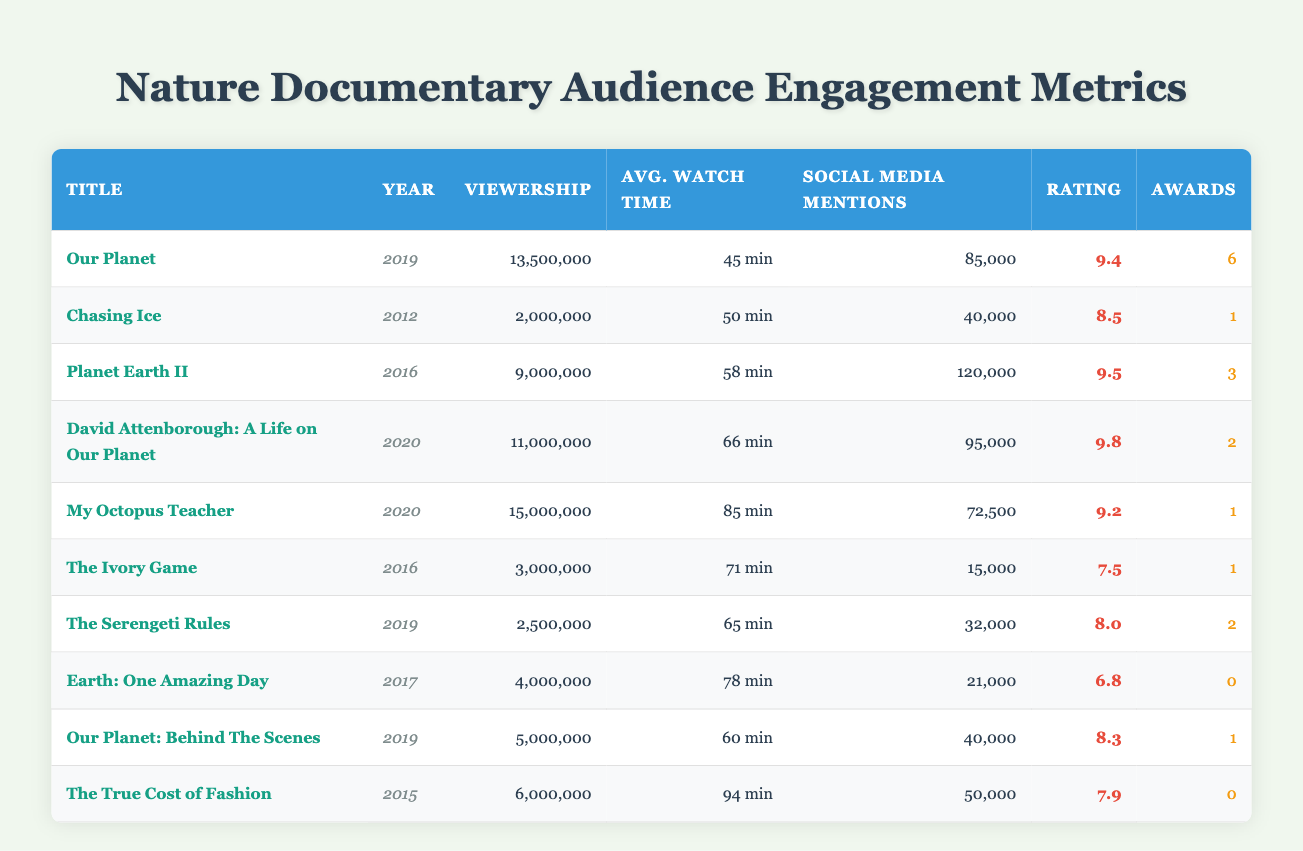What nature documentary had the highest viewership? By looking at the viewership numbers in the table, "My Octopus Teacher" has the highest viewership at 15,000,000.
Answer: My Octopus Teacher Which nature documentary won the most awards? From the table, "Our Planet" won the most awards at 6.
Answer: Our Planet What is the average watch time for the documentaries released in 2020? First, add the average watch times of "David Attenborough: A Life on Our Planet" (66 min) and "My Octopus Teacher" (85 min) to get 151 minutes. There are 2 documentaries, so divide by 2: 151/2 = 75.5 minutes.
Answer: 75.5 minutes Which documentary has a critical acclaim rating below 8.0? Looking through the critical acclaim ratings, "Earth: One Amazing Day" has a rating of 6.8, which is below 8.0.
Answer: Earth: One Amazing Day What is the total viewership for documentaries released in 2019? The documentaries released in 2019 are "Our Planet" (13,500,000), "The Serengeti Rules" (2,500,000), and "Our Planet: Behind The Scenes" (5,000,000). The total viewership is 13,500,000 + 2,500,000 + 5,000,000 = 21,000,000.
Answer: 21,000,000 How many social media mentions did "Planet Earth II" receive? The table lists that "Planet Earth II" received 120,000 social media mentions.
Answer: 120,000 Is the average watch time of "The True Cost of Fashion" higher than the average watch time of "The Ivory Game"? "The True Cost of Fashion" has an average watch time of 94 minutes, while "The Ivory Game" has 71 minutes. Since 94 is greater than 71, the answer is yes.
Answer: Yes What is the critical acclaim rating of the documentary with the most social media mentions? "Planet Earth II" has the highest social media mentions at 120,000 and also has a critical acclaim rating of 9.5.
Answer: 9.5 What is the sum of awards won by documentaries released between 2016 and 2019? The documentaries from that period are "Planet Earth II" (3), "The Ivory Game" (1), "Our Planet" (6), "The Serengeti Rules" (2), and "Our Planet: Behind The Scenes" (1). The sum is 3 + 1 + 6 + 2 + 1 = 13.
Answer: 13 Which documentary has the lowest average watch time? "Earth: One Amazing Day" has the lowest average watch time at 78 minutes compared to the other documentaries listed.
Answer: Earth: One Amazing Day What was the viewership difference between "My Octopus Teacher" and "David Attenborough: A Life on Our Planet"? "My Octopus Teacher" had a viewership of 15,000,000, while "David Attenborough: A Life on Our Planet" had 11,000,000. The difference is 15,000,000 - 11,000,000 = 4,000,000.
Answer: 4,000,000 